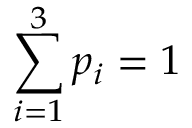Convert formula to latex. <formula><loc_0><loc_0><loc_500><loc_500>\sum _ { i = 1 } ^ { 3 } p _ { i } = 1</formula> 